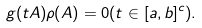Convert formula to latex. <formula><loc_0><loc_0><loc_500><loc_500>g ( t A ) \rho ( A ) = 0 ( t \in [ a , b ] ^ { c } ) .</formula> 